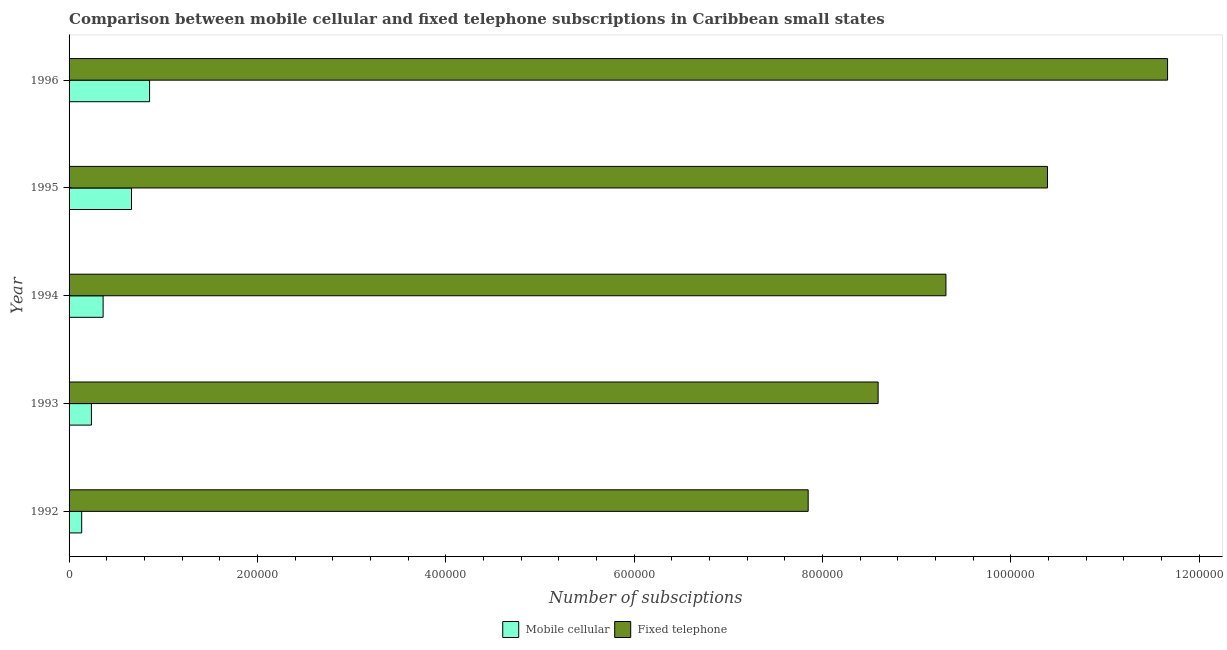How many different coloured bars are there?
Provide a succinct answer. 2. How many groups of bars are there?
Provide a succinct answer. 5. Are the number of bars per tick equal to the number of legend labels?
Provide a short and direct response. Yes. How many bars are there on the 5th tick from the top?
Provide a short and direct response. 2. What is the number of fixed telephone subscriptions in 1995?
Keep it short and to the point. 1.04e+06. Across all years, what is the maximum number of fixed telephone subscriptions?
Your answer should be compact. 1.17e+06. Across all years, what is the minimum number of fixed telephone subscriptions?
Ensure brevity in your answer.  7.85e+05. What is the total number of fixed telephone subscriptions in the graph?
Your answer should be compact. 4.78e+06. What is the difference between the number of mobile cellular subscriptions in 1995 and that in 1996?
Give a very brief answer. -1.92e+04. What is the difference between the number of fixed telephone subscriptions in 1992 and the number of mobile cellular subscriptions in 1995?
Give a very brief answer. 7.19e+05. What is the average number of fixed telephone subscriptions per year?
Your answer should be very brief. 9.56e+05. In the year 1992, what is the difference between the number of mobile cellular subscriptions and number of fixed telephone subscriptions?
Keep it short and to the point. -7.72e+05. What is the ratio of the number of fixed telephone subscriptions in 1993 to that in 1996?
Make the answer very short. 0.74. Is the number of fixed telephone subscriptions in 1993 less than that in 1995?
Your answer should be compact. Yes. Is the difference between the number of fixed telephone subscriptions in 1992 and 1995 greater than the difference between the number of mobile cellular subscriptions in 1992 and 1995?
Ensure brevity in your answer.  No. What is the difference between the highest and the second highest number of mobile cellular subscriptions?
Provide a succinct answer. 1.92e+04. What is the difference between the highest and the lowest number of mobile cellular subscriptions?
Keep it short and to the point. 7.21e+04. In how many years, is the number of fixed telephone subscriptions greater than the average number of fixed telephone subscriptions taken over all years?
Offer a very short reply. 2. Is the sum of the number of mobile cellular subscriptions in 1992 and 1994 greater than the maximum number of fixed telephone subscriptions across all years?
Your response must be concise. No. What does the 1st bar from the top in 1994 represents?
Provide a succinct answer. Fixed telephone. What does the 2nd bar from the bottom in 1994 represents?
Provide a short and direct response. Fixed telephone. How many bars are there?
Provide a succinct answer. 10. How many years are there in the graph?
Offer a very short reply. 5. Are the values on the major ticks of X-axis written in scientific E-notation?
Your response must be concise. No. Does the graph contain any zero values?
Give a very brief answer. No. Where does the legend appear in the graph?
Make the answer very short. Bottom center. How many legend labels are there?
Your answer should be very brief. 2. What is the title of the graph?
Offer a terse response. Comparison between mobile cellular and fixed telephone subscriptions in Caribbean small states. Does "Canada" appear as one of the legend labels in the graph?
Provide a succinct answer. No. What is the label or title of the X-axis?
Keep it short and to the point. Number of subsciptions. What is the Number of subsciptions of Mobile cellular in 1992?
Your answer should be very brief. 1.34e+04. What is the Number of subsciptions of Fixed telephone in 1992?
Make the answer very short. 7.85e+05. What is the Number of subsciptions in Mobile cellular in 1993?
Your response must be concise. 2.37e+04. What is the Number of subsciptions of Fixed telephone in 1993?
Ensure brevity in your answer.  8.59e+05. What is the Number of subsciptions of Mobile cellular in 1994?
Provide a succinct answer. 3.62e+04. What is the Number of subsciptions of Fixed telephone in 1994?
Keep it short and to the point. 9.31e+05. What is the Number of subsciptions of Mobile cellular in 1995?
Your answer should be compact. 6.63e+04. What is the Number of subsciptions of Fixed telephone in 1995?
Keep it short and to the point. 1.04e+06. What is the Number of subsciptions of Mobile cellular in 1996?
Keep it short and to the point. 8.55e+04. What is the Number of subsciptions of Fixed telephone in 1996?
Give a very brief answer. 1.17e+06. Across all years, what is the maximum Number of subsciptions in Mobile cellular?
Your response must be concise. 8.55e+04. Across all years, what is the maximum Number of subsciptions in Fixed telephone?
Ensure brevity in your answer.  1.17e+06. Across all years, what is the minimum Number of subsciptions in Mobile cellular?
Provide a short and direct response. 1.34e+04. Across all years, what is the minimum Number of subsciptions of Fixed telephone?
Keep it short and to the point. 7.85e+05. What is the total Number of subsciptions of Mobile cellular in the graph?
Give a very brief answer. 2.25e+05. What is the total Number of subsciptions in Fixed telephone in the graph?
Offer a terse response. 4.78e+06. What is the difference between the Number of subsciptions in Mobile cellular in 1992 and that in 1993?
Ensure brevity in your answer.  -1.03e+04. What is the difference between the Number of subsciptions in Fixed telephone in 1992 and that in 1993?
Your answer should be compact. -7.43e+04. What is the difference between the Number of subsciptions of Mobile cellular in 1992 and that in 1994?
Give a very brief answer. -2.28e+04. What is the difference between the Number of subsciptions in Fixed telephone in 1992 and that in 1994?
Give a very brief answer. -1.46e+05. What is the difference between the Number of subsciptions in Mobile cellular in 1992 and that in 1995?
Offer a very short reply. -5.29e+04. What is the difference between the Number of subsciptions of Fixed telephone in 1992 and that in 1995?
Offer a very short reply. -2.54e+05. What is the difference between the Number of subsciptions of Mobile cellular in 1992 and that in 1996?
Keep it short and to the point. -7.21e+04. What is the difference between the Number of subsciptions of Fixed telephone in 1992 and that in 1996?
Give a very brief answer. -3.82e+05. What is the difference between the Number of subsciptions of Mobile cellular in 1993 and that in 1994?
Provide a succinct answer. -1.24e+04. What is the difference between the Number of subsciptions in Fixed telephone in 1993 and that in 1994?
Provide a short and direct response. -7.20e+04. What is the difference between the Number of subsciptions in Mobile cellular in 1993 and that in 1995?
Make the answer very short. -4.26e+04. What is the difference between the Number of subsciptions in Fixed telephone in 1993 and that in 1995?
Give a very brief answer. -1.80e+05. What is the difference between the Number of subsciptions in Mobile cellular in 1993 and that in 1996?
Your answer should be compact. -6.18e+04. What is the difference between the Number of subsciptions in Fixed telephone in 1993 and that in 1996?
Make the answer very short. -3.07e+05. What is the difference between the Number of subsciptions of Mobile cellular in 1994 and that in 1995?
Your answer should be compact. -3.01e+04. What is the difference between the Number of subsciptions in Fixed telephone in 1994 and that in 1995?
Your answer should be compact. -1.08e+05. What is the difference between the Number of subsciptions in Mobile cellular in 1994 and that in 1996?
Offer a very short reply. -4.94e+04. What is the difference between the Number of subsciptions of Fixed telephone in 1994 and that in 1996?
Your response must be concise. -2.35e+05. What is the difference between the Number of subsciptions of Mobile cellular in 1995 and that in 1996?
Make the answer very short. -1.92e+04. What is the difference between the Number of subsciptions in Fixed telephone in 1995 and that in 1996?
Your answer should be very brief. -1.28e+05. What is the difference between the Number of subsciptions in Mobile cellular in 1992 and the Number of subsciptions in Fixed telephone in 1993?
Make the answer very short. -8.46e+05. What is the difference between the Number of subsciptions of Mobile cellular in 1992 and the Number of subsciptions of Fixed telephone in 1994?
Your response must be concise. -9.18e+05. What is the difference between the Number of subsciptions of Mobile cellular in 1992 and the Number of subsciptions of Fixed telephone in 1995?
Make the answer very short. -1.03e+06. What is the difference between the Number of subsciptions of Mobile cellular in 1992 and the Number of subsciptions of Fixed telephone in 1996?
Give a very brief answer. -1.15e+06. What is the difference between the Number of subsciptions in Mobile cellular in 1993 and the Number of subsciptions in Fixed telephone in 1994?
Provide a succinct answer. -9.08e+05. What is the difference between the Number of subsciptions of Mobile cellular in 1993 and the Number of subsciptions of Fixed telephone in 1995?
Provide a succinct answer. -1.02e+06. What is the difference between the Number of subsciptions in Mobile cellular in 1993 and the Number of subsciptions in Fixed telephone in 1996?
Offer a terse response. -1.14e+06. What is the difference between the Number of subsciptions of Mobile cellular in 1994 and the Number of subsciptions of Fixed telephone in 1995?
Offer a terse response. -1.00e+06. What is the difference between the Number of subsciptions in Mobile cellular in 1994 and the Number of subsciptions in Fixed telephone in 1996?
Offer a very short reply. -1.13e+06. What is the difference between the Number of subsciptions in Mobile cellular in 1995 and the Number of subsciptions in Fixed telephone in 1996?
Keep it short and to the point. -1.10e+06. What is the average Number of subsciptions of Mobile cellular per year?
Your answer should be very brief. 4.50e+04. What is the average Number of subsciptions of Fixed telephone per year?
Offer a very short reply. 9.56e+05. In the year 1992, what is the difference between the Number of subsciptions of Mobile cellular and Number of subsciptions of Fixed telephone?
Make the answer very short. -7.72e+05. In the year 1993, what is the difference between the Number of subsciptions of Mobile cellular and Number of subsciptions of Fixed telephone?
Provide a short and direct response. -8.35e+05. In the year 1994, what is the difference between the Number of subsciptions in Mobile cellular and Number of subsciptions in Fixed telephone?
Provide a succinct answer. -8.95e+05. In the year 1995, what is the difference between the Number of subsciptions in Mobile cellular and Number of subsciptions in Fixed telephone?
Ensure brevity in your answer.  -9.73e+05. In the year 1996, what is the difference between the Number of subsciptions in Mobile cellular and Number of subsciptions in Fixed telephone?
Keep it short and to the point. -1.08e+06. What is the ratio of the Number of subsciptions of Mobile cellular in 1992 to that in 1993?
Keep it short and to the point. 0.56. What is the ratio of the Number of subsciptions of Fixed telephone in 1992 to that in 1993?
Offer a terse response. 0.91. What is the ratio of the Number of subsciptions of Mobile cellular in 1992 to that in 1994?
Give a very brief answer. 0.37. What is the ratio of the Number of subsciptions in Fixed telephone in 1992 to that in 1994?
Give a very brief answer. 0.84. What is the ratio of the Number of subsciptions of Mobile cellular in 1992 to that in 1995?
Your answer should be very brief. 0.2. What is the ratio of the Number of subsciptions of Fixed telephone in 1992 to that in 1995?
Provide a short and direct response. 0.76. What is the ratio of the Number of subsciptions of Mobile cellular in 1992 to that in 1996?
Keep it short and to the point. 0.16. What is the ratio of the Number of subsciptions in Fixed telephone in 1992 to that in 1996?
Offer a terse response. 0.67. What is the ratio of the Number of subsciptions in Mobile cellular in 1993 to that in 1994?
Offer a very short reply. 0.66. What is the ratio of the Number of subsciptions of Fixed telephone in 1993 to that in 1994?
Provide a short and direct response. 0.92. What is the ratio of the Number of subsciptions of Mobile cellular in 1993 to that in 1995?
Your response must be concise. 0.36. What is the ratio of the Number of subsciptions of Fixed telephone in 1993 to that in 1995?
Ensure brevity in your answer.  0.83. What is the ratio of the Number of subsciptions of Mobile cellular in 1993 to that in 1996?
Make the answer very short. 0.28. What is the ratio of the Number of subsciptions of Fixed telephone in 1993 to that in 1996?
Your answer should be very brief. 0.74. What is the ratio of the Number of subsciptions of Mobile cellular in 1994 to that in 1995?
Your answer should be compact. 0.55. What is the ratio of the Number of subsciptions of Fixed telephone in 1994 to that in 1995?
Offer a very short reply. 0.9. What is the ratio of the Number of subsciptions of Mobile cellular in 1994 to that in 1996?
Give a very brief answer. 0.42. What is the ratio of the Number of subsciptions in Fixed telephone in 1994 to that in 1996?
Ensure brevity in your answer.  0.8. What is the ratio of the Number of subsciptions of Mobile cellular in 1995 to that in 1996?
Offer a very short reply. 0.78. What is the ratio of the Number of subsciptions in Fixed telephone in 1995 to that in 1996?
Your answer should be compact. 0.89. What is the difference between the highest and the second highest Number of subsciptions of Mobile cellular?
Offer a very short reply. 1.92e+04. What is the difference between the highest and the second highest Number of subsciptions of Fixed telephone?
Make the answer very short. 1.28e+05. What is the difference between the highest and the lowest Number of subsciptions in Mobile cellular?
Your answer should be very brief. 7.21e+04. What is the difference between the highest and the lowest Number of subsciptions in Fixed telephone?
Your answer should be compact. 3.82e+05. 